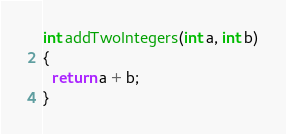<code> <loc_0><loc_0><loc_500><loc_500><_C_>int addTwoIntegers(int a, int b)
{
  return a + b;
}</code> 